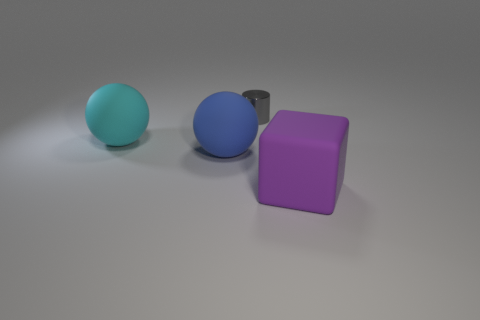The big thing to the right of the ball right of the large cyan sphere is what color?
Your answer should be very brief. Purple. Are there any small things that have the same color as the small metal cylinder?
Offer a very short reply. No. How big is the sphere that is to the right of the rubber ball behind the big sphere that is on the right side of the large cyan ball?
Your response must be concise. Large. There is a big purple matte thing; is its shape the same as the object left of the blue rubber sphere?
Give a very brief answer. No. What number of other objects are there of the same size as the blue rubber object?
Offer a terse response. 2. There is a object that is behind the cyan ball; how big is it?
Your answer should be compact. Small. How many cylinders have the same material as the block?
Your answer should be compact. 0. Do the large rubber object on the right side of the gray thing and the gray thing have the same shape?
Provide a succinct answer. No. What shape is the big matte object that is to the right of the gray cylinder?
Provide a succinct answer. Cube. What material is the small gray object?
Your answer should be very brief. Metal. 